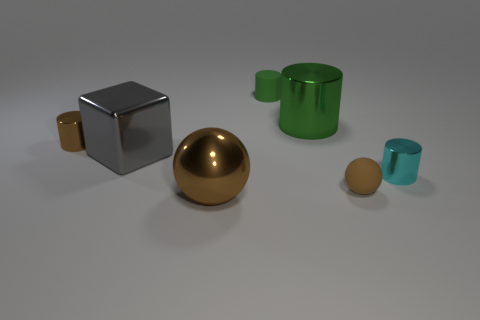Is the number of small brown objects to the right of the tiny brown metallic object the same as the number of green cylinders on the left side of the big gray shiny cube?
Make the answer very short. No. There is a gray metal thing; does it have the same size as the metal cylinder to the left of the large brown ball?
Offer a very short reply. No. Are there more tiny brown objects that are to the right of the tiny green matte thing than tiny red metallic spheres?
Your response must be concise. Yes. What number of other cylinders have the same size as the brown metal cylinder?
Your response must be concise. 2. Does the brown metal thing that is in front of the tiny cyan cylinder have the same size as the matte object behind the cyan shiny cylinder?
Offer a very short reply. No. Are there more small cyan cylinders that are behind the big green shiny cylinder than tiny green cylinders in front of the small cyan shiny cylinder?
Offer a very short reply. No. What number of big red matte things have the same shape as the tiny green matte object?
Provide a short and direct response. 0. There is another brown cylinder that is the same size as the matte cylinder; what is it made of?
Provide a short and direct response. Metal. Are there any large brown cylinders that have the same material as the big brown ball?
Your answer should be compact. No. Is the number of green rubber cylinders in front of the brown metallic ball less than the number of brown metal objects?
Ensure brevity in your answer.  Yes. 